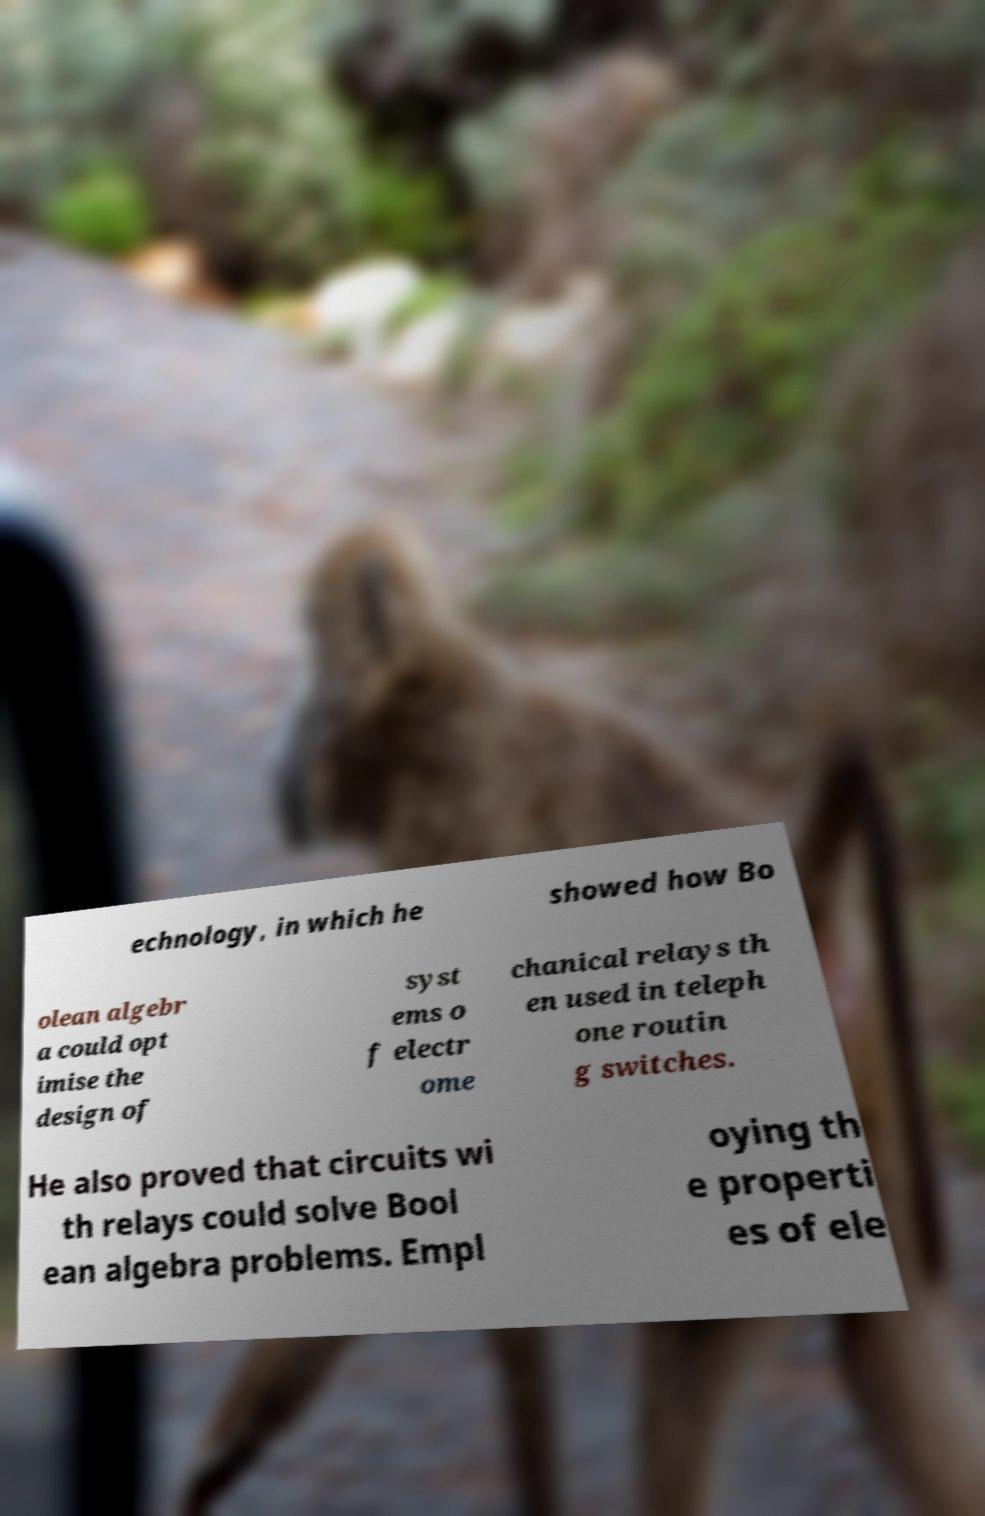I need the written content from this picture converted into text. Can you do that? echnology, in which he showed how Bo olean algebr a could opt imise the design of syst ems o f electr ome chanical relays th en used in teleph one routin g switches. He also proved that circuits wi th relays could solve Bool ean algebra problems. Empl oying th e properti es of ele 